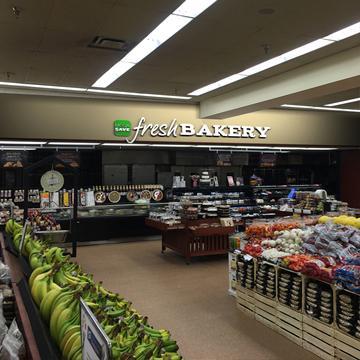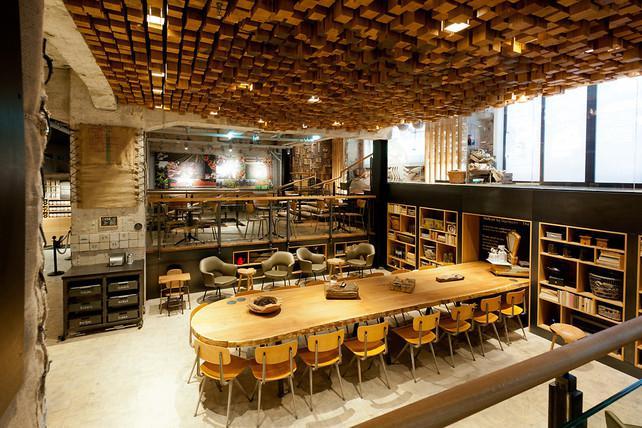The first image is the image on the left, the second image is the image on the right. Analyze the images presented: Is the assertion "In the store there are labels to show a combine bakery and deli." valid? Answer yes or no. No. The first image is the image on the left, the second image is the image on the right. For the images shown, is this caption "The bakery sign is in a frame with a rounded top." true? Answer yes or no. No. 